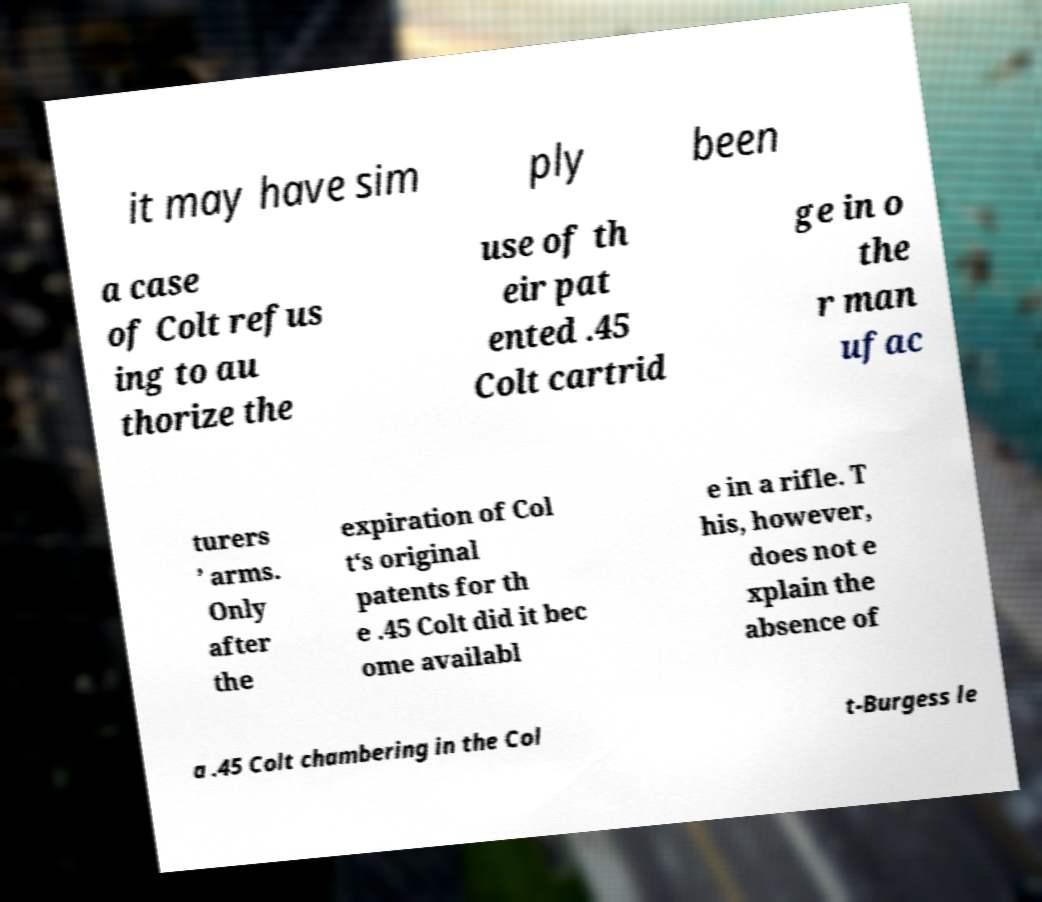For documentation purposes, I need the text within this image transcribed. Could you provide that? it may have sim ply been a case of Colt refus ing to au thorize the use of th eir pat ented .45 Colt cartrid ge in o the r man ufac turers ’ arms. Only after the expiration of Col t‘s original patents for th e .45 Colt did it bec ome availabl e in a rifle. T his, however, does not e xplain the absence of a .45 Colt chambering in the Col t-Burgess le 